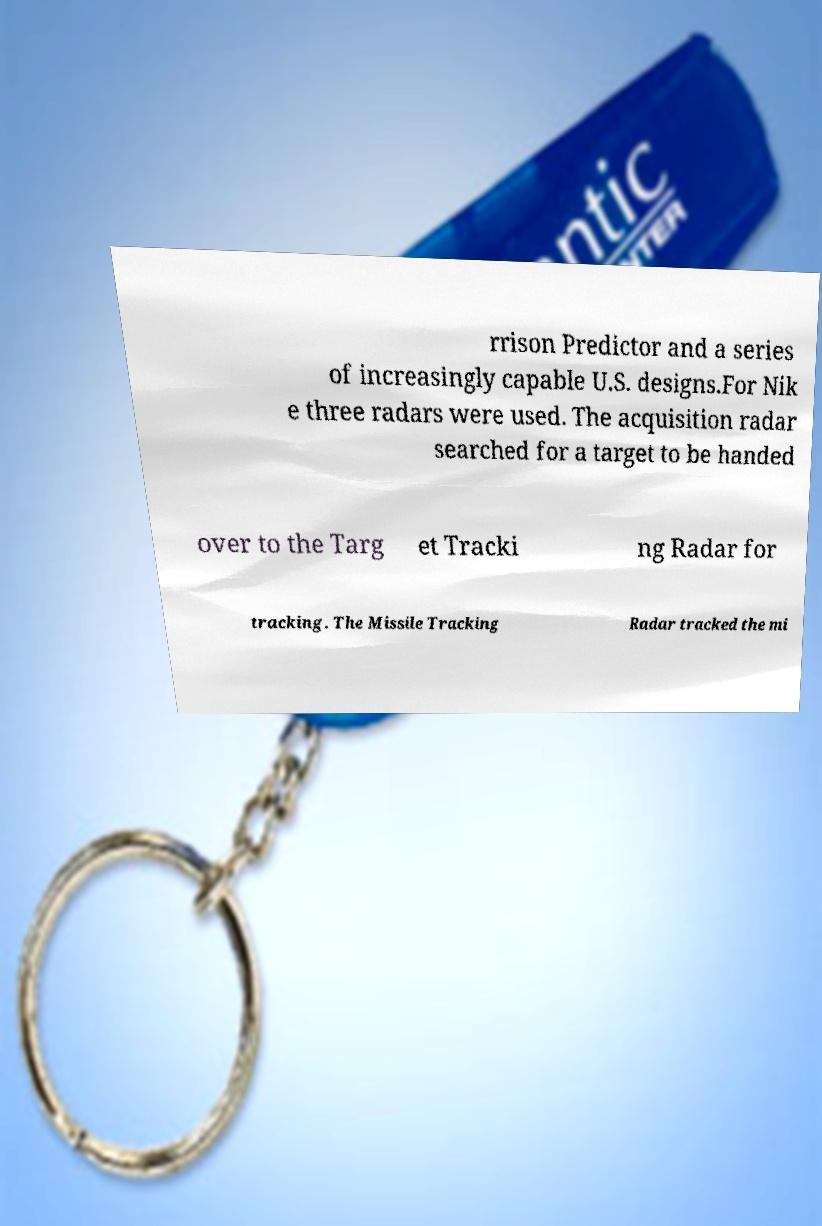Can you accurately transcribe the text from the provided image for me? rrison Predictor and a series of increasingly capable U.S. designs.For Nik e three radars were used. The acquisition radar searched for a target to be handed over to the Targ et Tracki ng Radar for tracking. The Missile Tracking Radar tracked the mi 